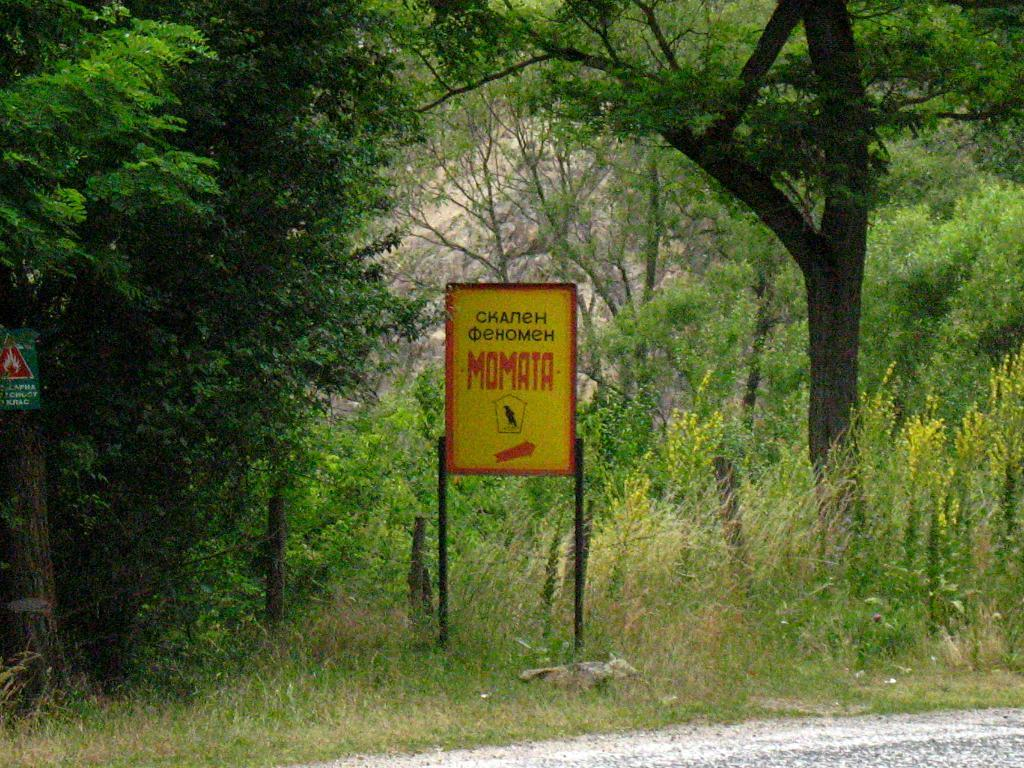<image>
Describe the image concisely. a sign for MOMATA with cyrillic writing in the woods 